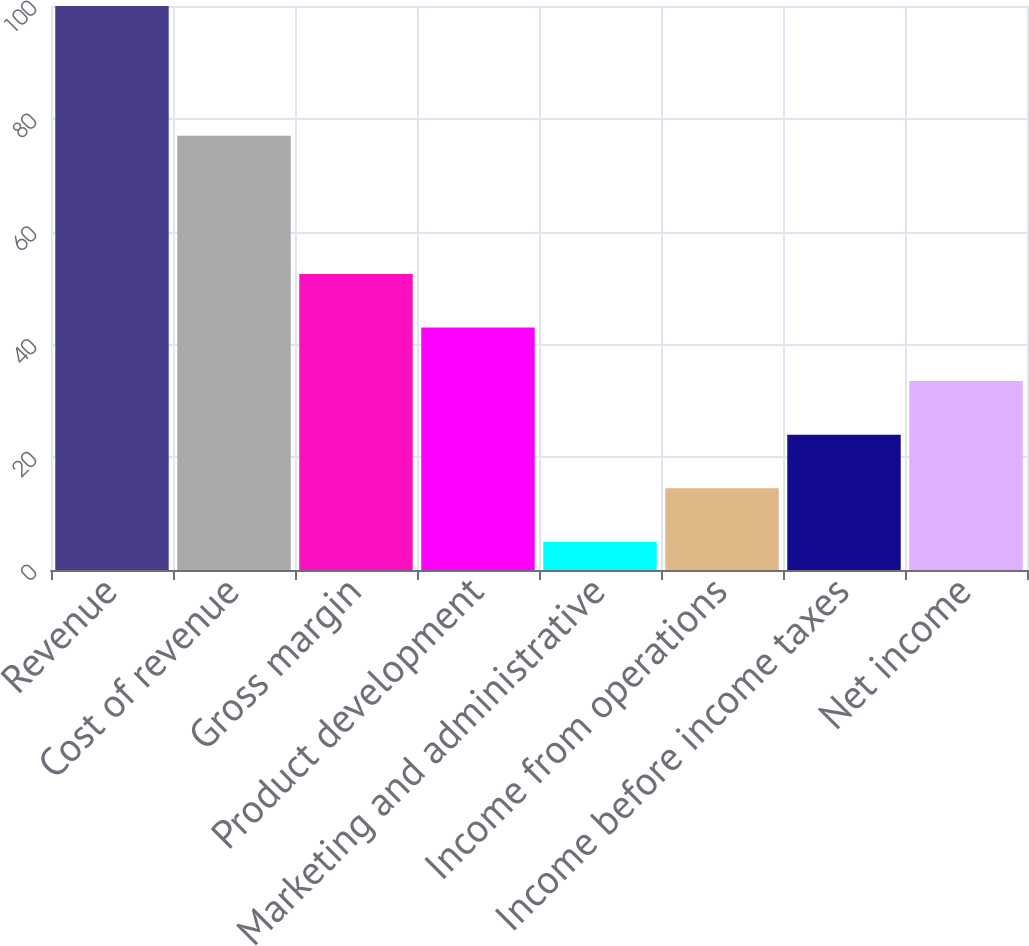Convert chart. <chart><loc_0><loc_0><loc_500><loc_500><bar_chart><fcel>Revenue<fcel>Cost of revenue<fcel>Gross margin<fcel>Product development<fcel>Marketing and administrative<fcel>Income from operations<fcel>Income before income taxes<fcel>Net income<nl><fcel>100<fcel>77<fcel>52.5<fcel>43<fcel>5<fcel>14.5<fcel>24<fcel>33.5<nl></chart> 